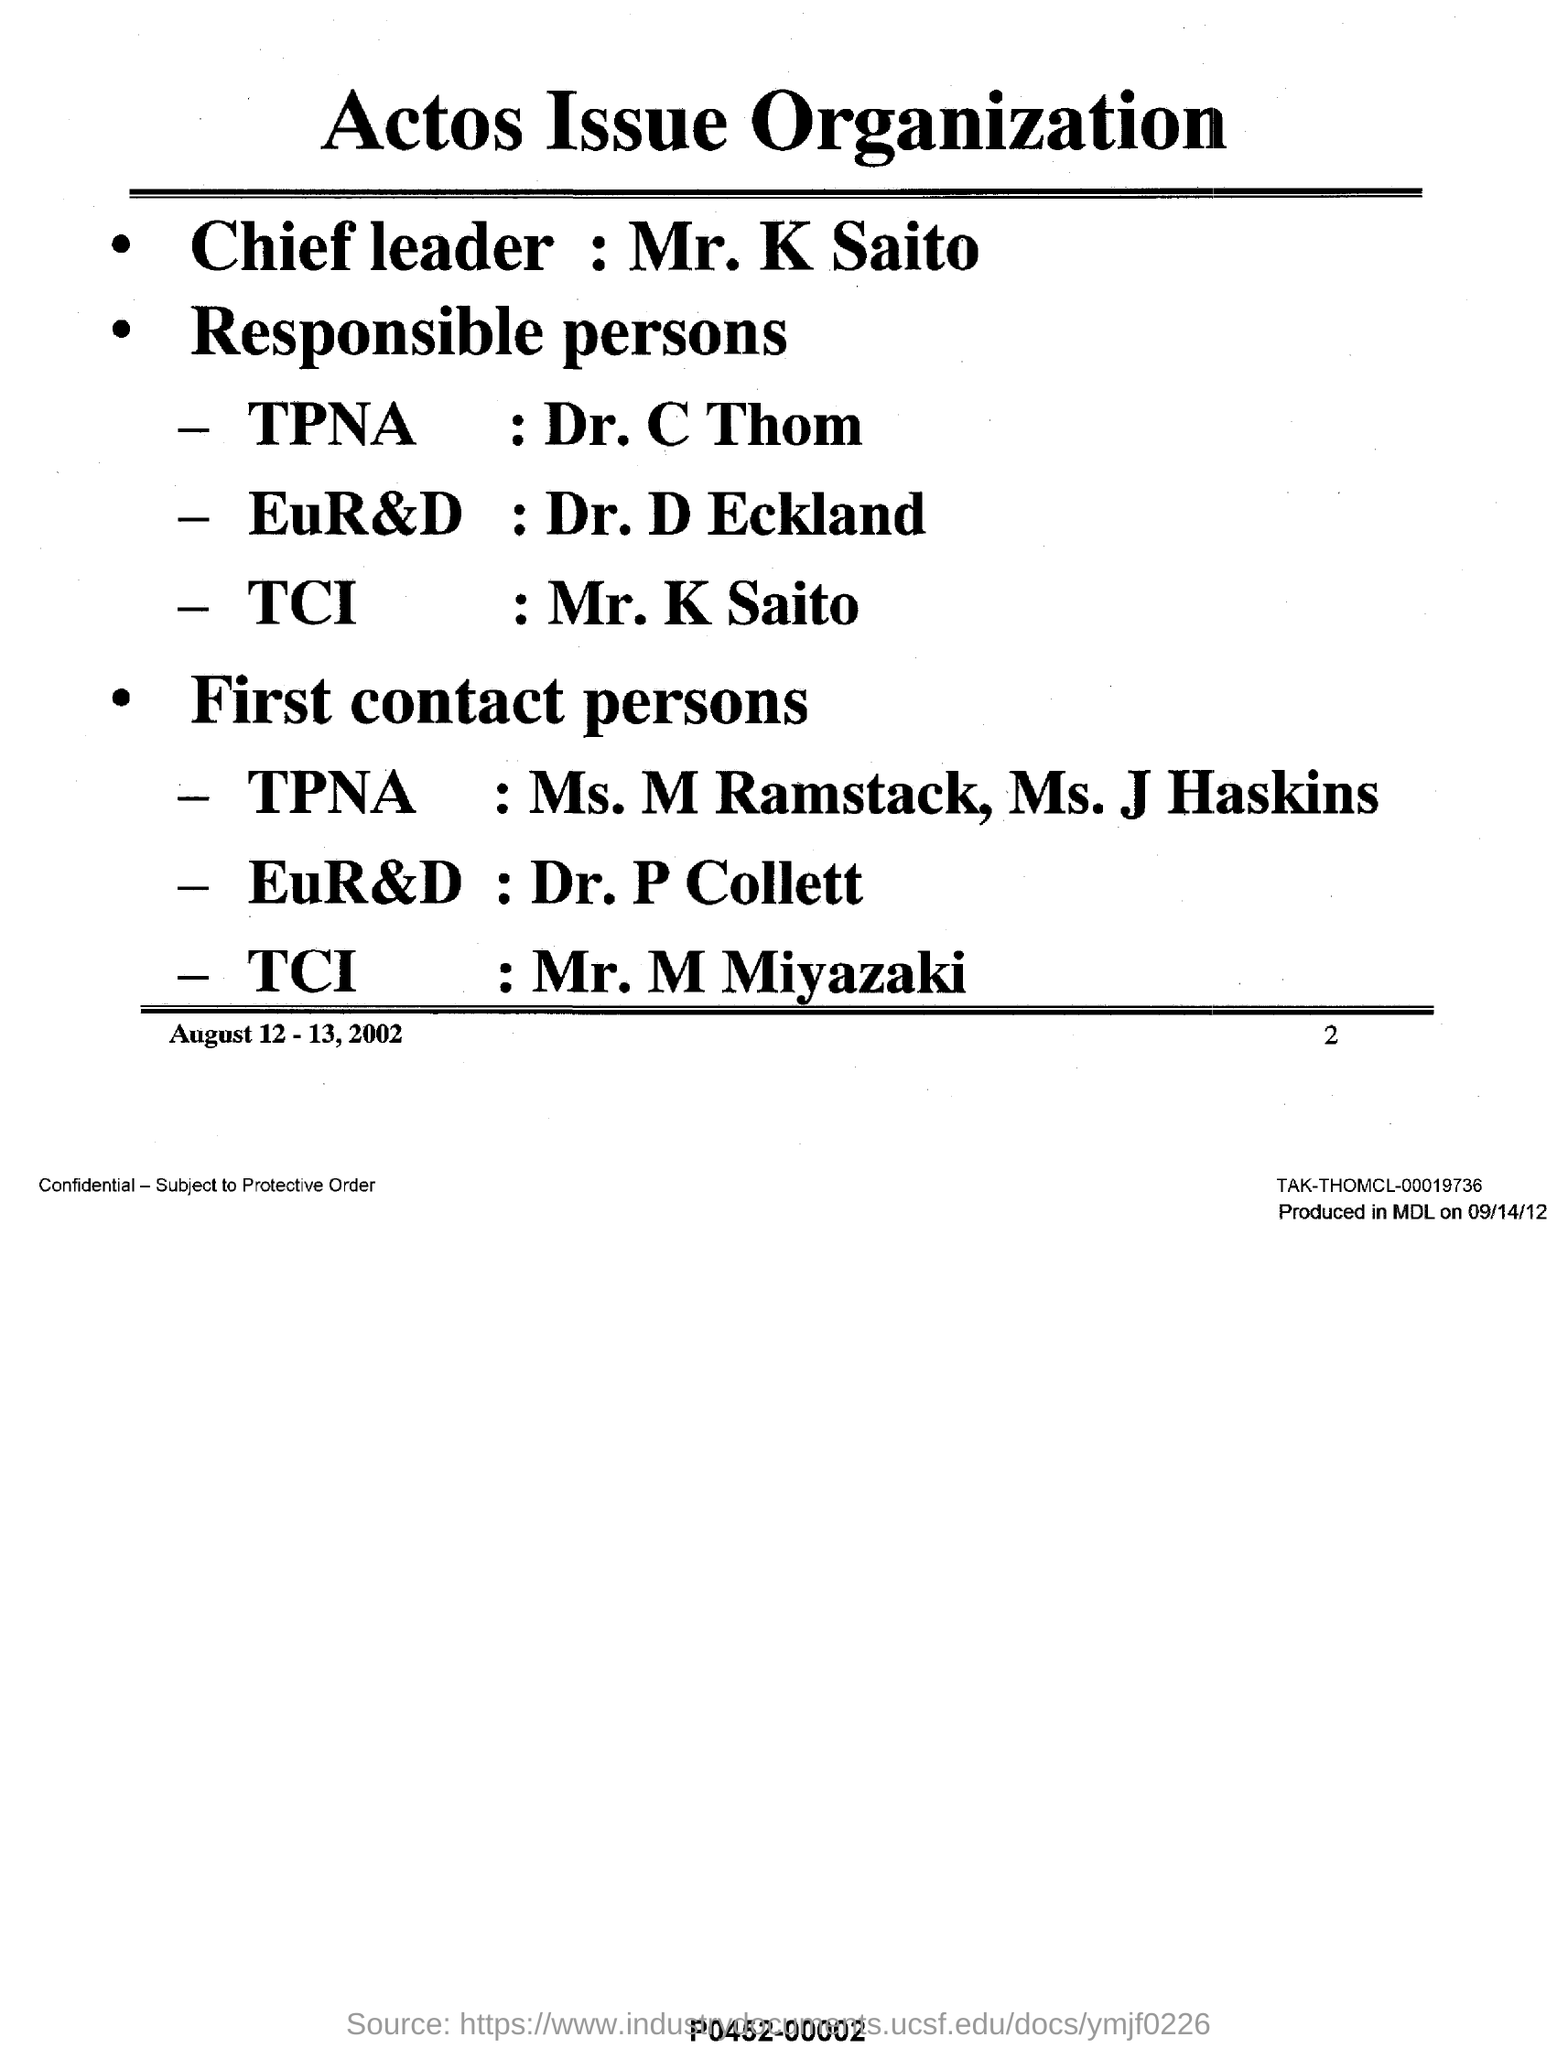Who is the chief leader ?
Offer a terse response. Mr.K Saito. Who is the responsible person for tpna ?
Your answer should be compact. Dr. C Thom. What is the name of the organization ?
Your answer should be compact. ACTOS ISSUE ORGANIZATION. Who is the responsible person of tci ?
Offer a terse response. MR. K SAITO. Who is the first contact person of eur&d ?
Your answer should be very brief. Dr. P Collett. Who is the responsible person for eur&d ?
Offer a very short reply. Dr. D Eckland. Who is the first contact person of tpna ?
Your answer should be very brief. MS. M RAMSTACK, MS. J HASKINS. Who is the first contact person of tci ?
Make the answer very short. MR. M MIYAZAKI. 